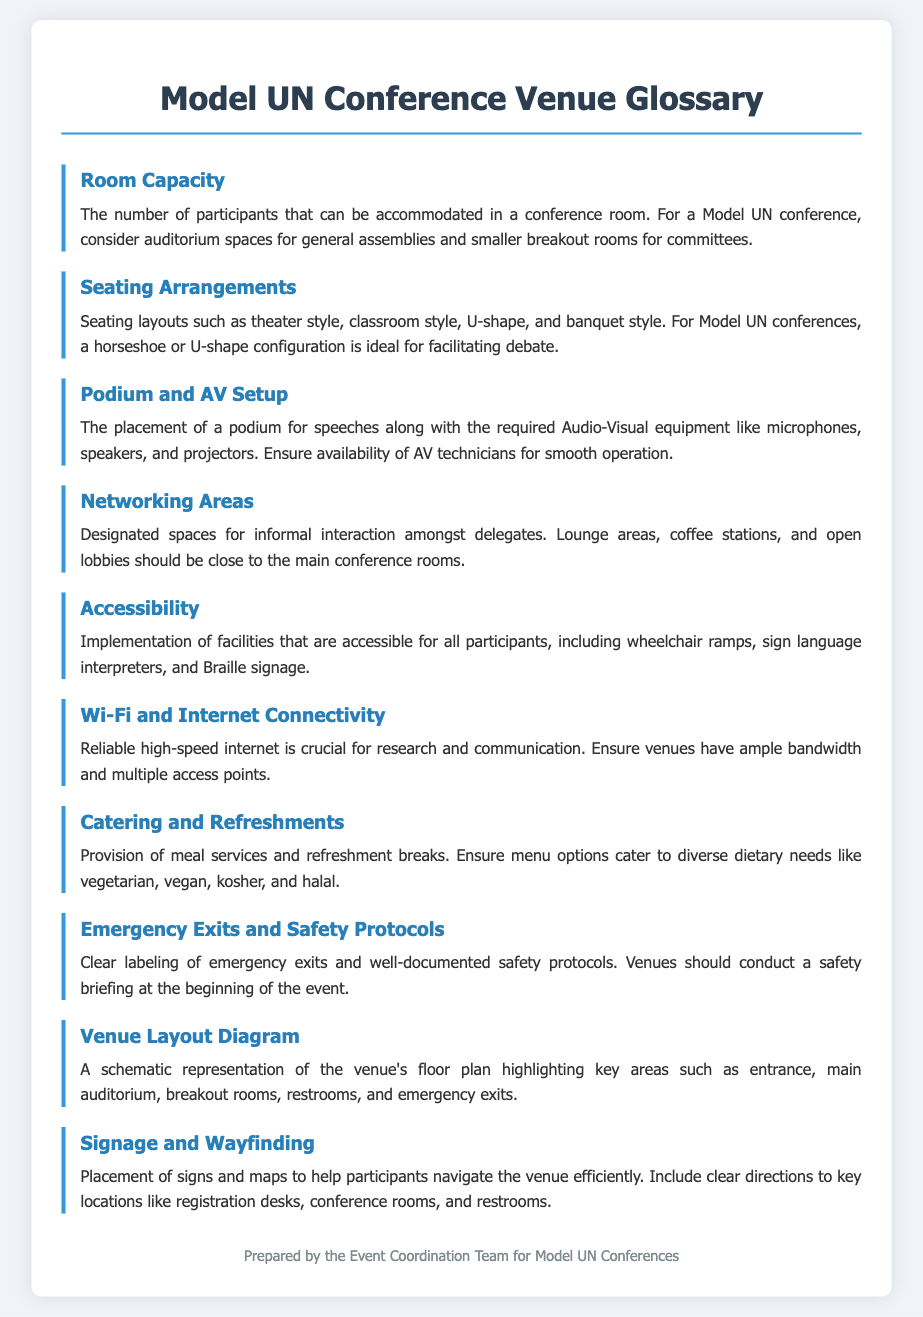What is the maximum number of participants a conference room can accommodate? The number of participants that can be accommodated in a conference room is referred to as room capacity.
Answer: Room Capacity What kind of seating layout is ideal for facilitating debate? For Model UN conferences, a horseshoe or U-shape configuration is ideal for facilitating debate.
Answer: Horseshoe or U-shape What is essential for the podium setup at the conference? Ensure availability of AV technicians for smooth operation during the podium and AV setup.
Answer: AV technicians What should networking areas include? Designated spaces for informal interaction, such as lounge areas and coffee stations, should be close to the main conference rooms.
Answer: Lounge areas, coffee stations What type of dietary options should catering provide? Ensure menu options cater to diverse dietary needs like vegetarian, vegan, kosher, and halal.
Answer: Vegetarian, vegan, kosher, and halal What does a venue layout diagram represent? A schematic representation of the venue's floor plan highlighting key areas such as entrance, main auditorium, breakout rooms, restrooms, and emergency exits.
Answer: Floor plan What kind of connectivity is crucial for participants? Reliable high-speed internet is crucial for research and communication.
Answer: High-speed internet What should venues conduct at the beginning of the event? Venues should conduct a safety briefing at the beginning of the event.
Answer: Safety briefing 